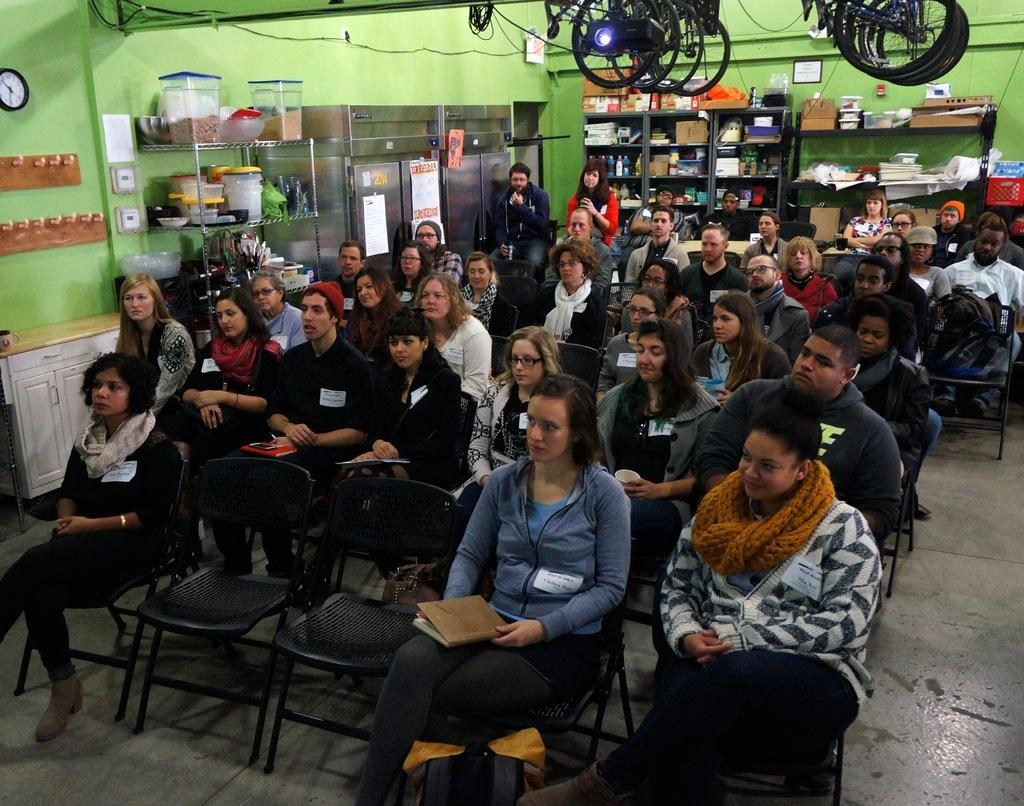What are the people in the image doing? There is a group of people sitting on chairs in the image. Where are the chairs located in the image? The chairs are on the left side of the image. What can be seen in the background of the image? There are buckets on a rack, blocks in a rack, a wall, and a frame visible in the background. What songs are being sung by the people in the image? There is no indication in the image that the people are singing songs, so it cannot be determined from the picture. 